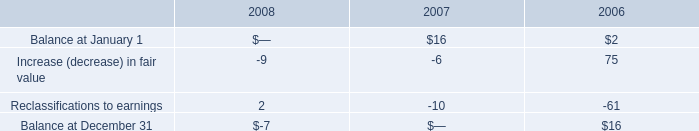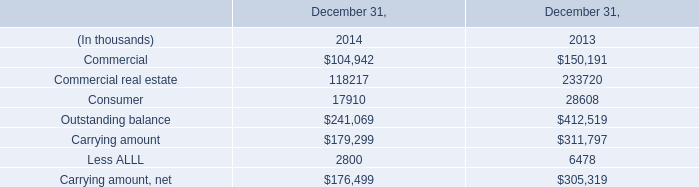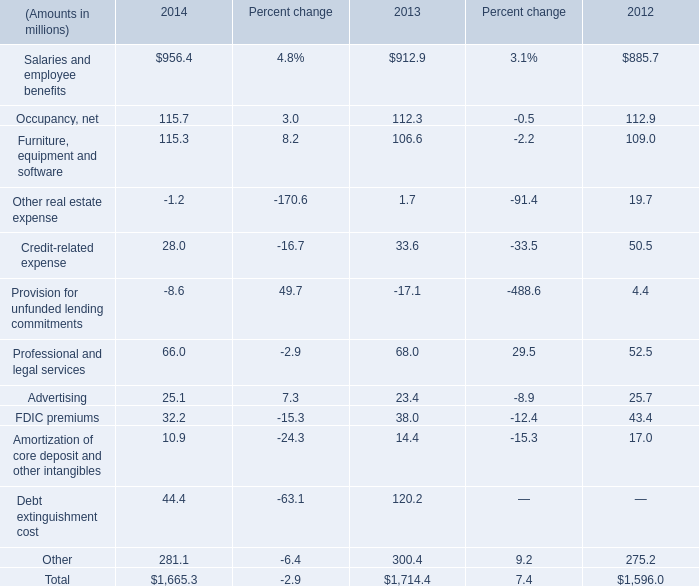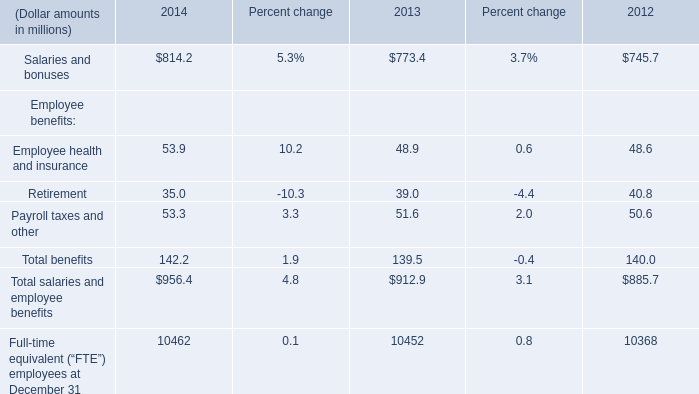For the year where the value of the Total salaries and employee benefits is the highest, what's the value of the Salaries and bonuses ? (in million) 
Answer: 814.2. 